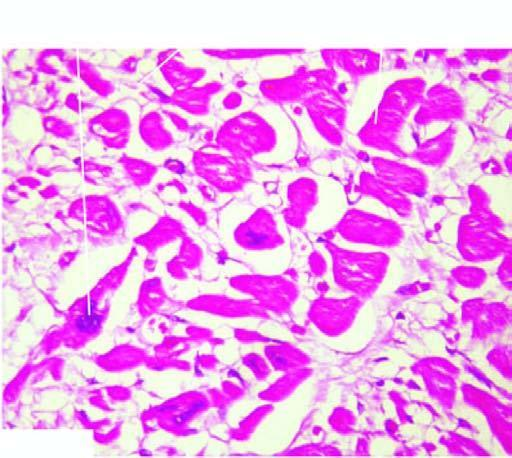re these cells also enlarged with irregular outlines?
Answer the question using a single word or phrase. No 